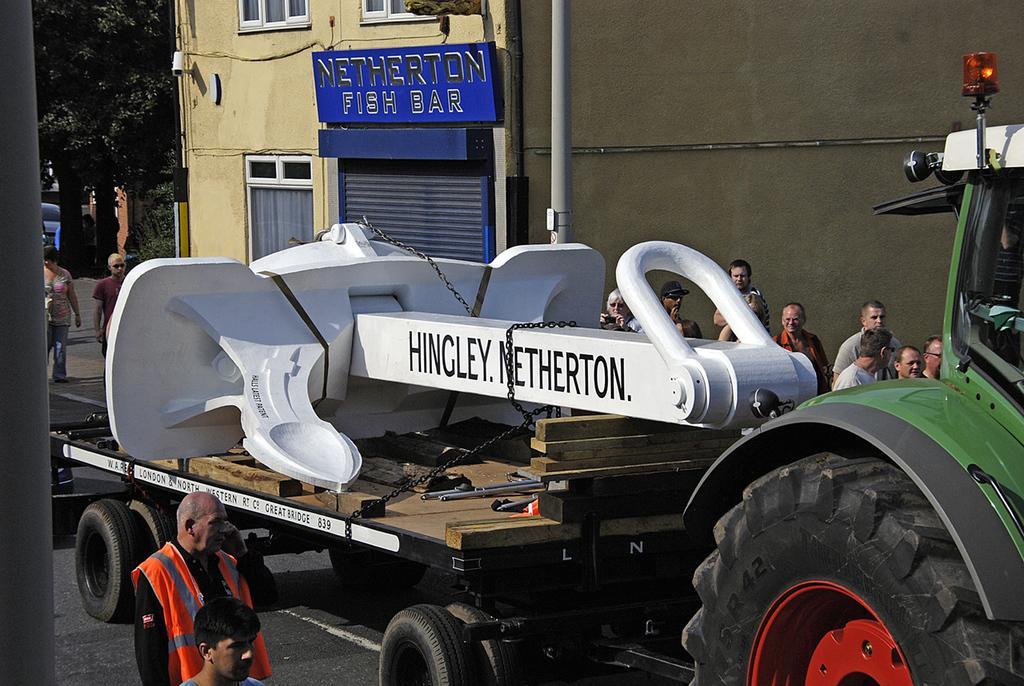Please provide a concise description of this image. Here there is a vehicle on the road, where people are standing, here there is a tree and this is building. 